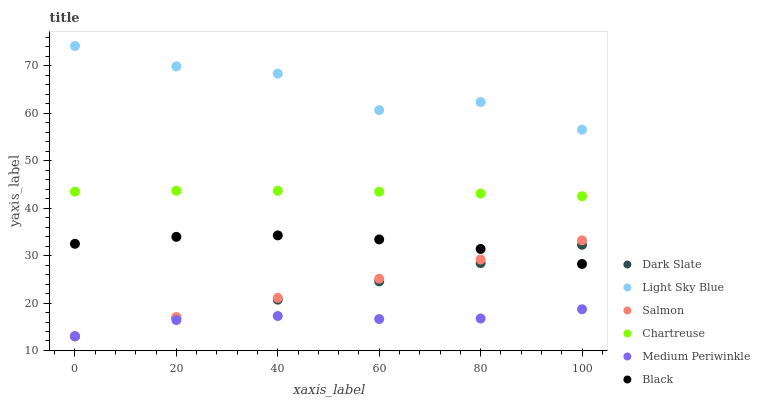Does Medium Periwinkle have the minimum area under the curve?
Answer yes or no. Yes. Does Light Sky Blue have the maximum area under the curve?
Answer yes or no. Yes. Does Salmon have the minimum area under the curve?
Answer yes or no. No. Does Salmon have the maximum area under the curve?
Answer yes or no. No. Is Dark Slate the smoothest?
Answer yes or no. Yes. Is Light Sky Blue the roughest?
Answer yes or no. Yes. Is Salmon the smoothest?
Answer yes or no. No. Is Salmon the roughest?
Answer yes or no. No. Does Medium Periwinkle have the lowest value?
Answer yes or no. Yes. Does Chartreuse have the lowest value?
Answer yes or no. No. Does Light Sky Blue have the highest value?
Answer yes or no. Yes. Does Salmon have the highest value?
Answer yes or no. No. Is Black less than Light Sky Blue?
Answer yes or no. Yes. Is Light Sky Blue greater than Black?
Answer yes or no. Yes. Does Dark Slate intersect Medium Periwinkle?
Answer yes or no. Yes. Is Dark Slate less than Medium Periwinkle?
Answer yes or no. No. Is Dark Slate greater than Medium Periwinkle?
Answer yes or no. No. Does Black intersect Light Sky Blue?
Answer yes or no. No. 